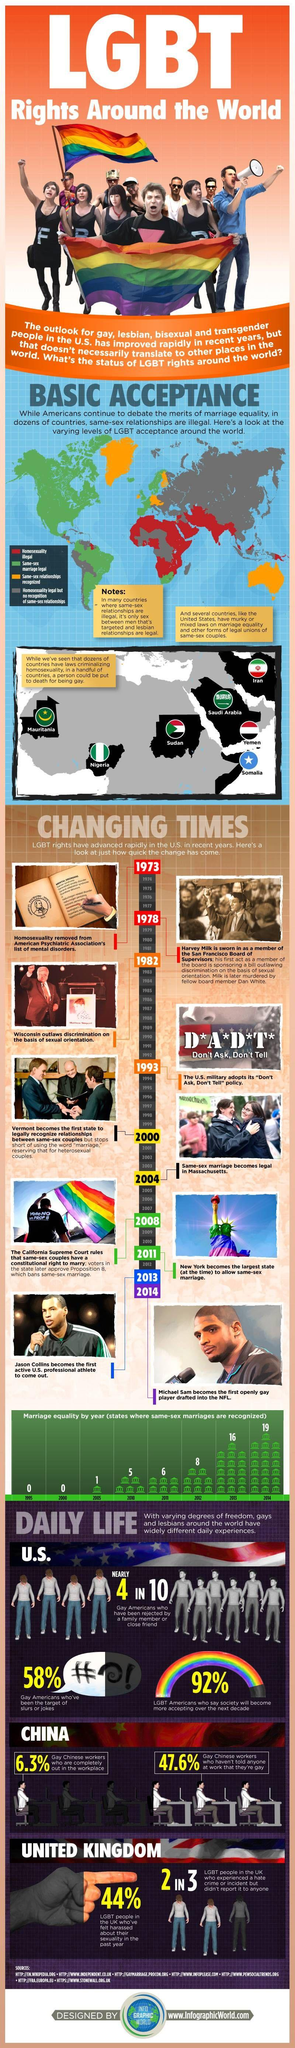Outline some significant characteristics in this image. In 2004, same-sex marriage became legal in the state of Massachusetts. In the year 2011, 11 states in the United States recognized the same-sex marriages. In 1982, Wisconsin became the first state to outlaw discrimination on the basis of sexual orientation. In 2013, 16 states in the United States recognized same-sex marriages. According to a recent study, 58% of Gay Americans have been the target of slurs or jokes. 